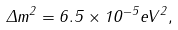<formula> <loc_0><loc_0><loc_500><loc_500>\Delta m ^ { 2 } = 6 . 5 \times 1 0 ^ { - 5 } e V ^ { 2 } ,</formula> 